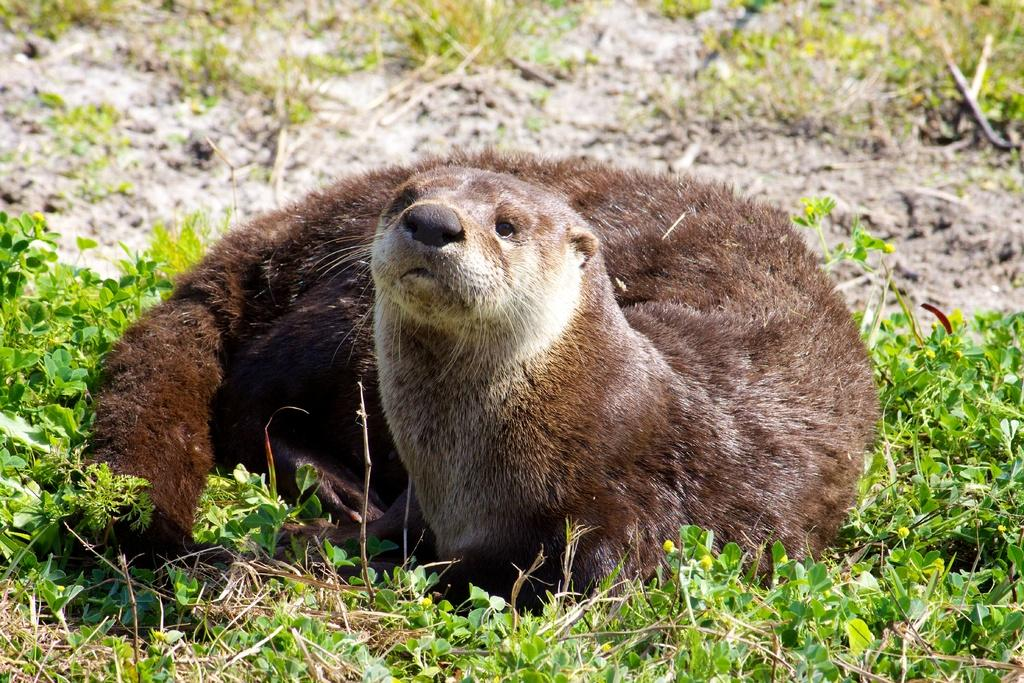What type of animal is present in the image? There is an animal in the image. What color is the animal in the image? The animal is in brown color. What is the animal resting on in the image? The animal is resting on grass. What type of trick or joke is the animal performing in the image? There is no indication in the image that the animal is performing any tricks or jokes. 